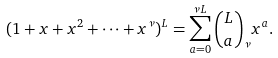<formula> <loc_0><loc_0><loc_500><loc_500>( 1 + x + x ^ { 2 } + \cdots + x ^ { \nu } ) ^ { L } = \sum _ { a = 0 } ^ { \nu L } \binom { L } { a } _ { \nu } x ^ { a } .</formula> 